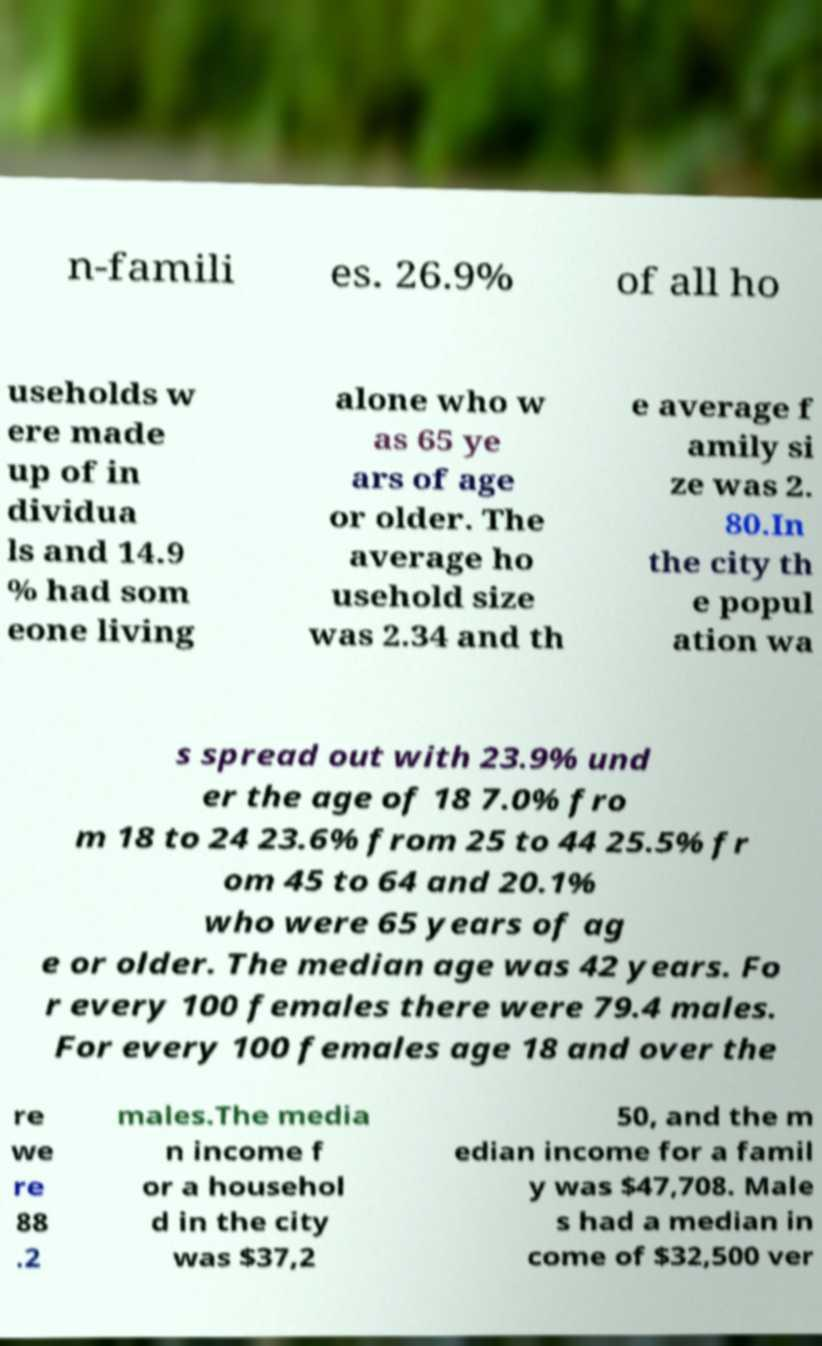Can you accurately transcribe the text from the provided image for me? n-famili es. 26.9% of all ho useholds w ere made up of in dividua ls and 14.9 % had som eone living alone who w as 65 ye ars of age or older. The average ho usehold size was 2.34 and th e average f amily si ze was 2. 80.In the city th e popul ation wa s spread out with 23.9% und er the age of 18 7.0% fro m 18 to 24 23.6% from 25 to 44 25.5% fr om 45 to 64 and 20.1% who were 65 years of ag e or older. The median age was 42 years. Fo r every 100 females there were 79.4 males. For every 100 females age 18 and over the re we re 88 .2 males.The media n income f or a househol d in the city was $37,2 50, and the m edian income for a famil y was $47,708. Male s had a median in come of $32,500 ver 